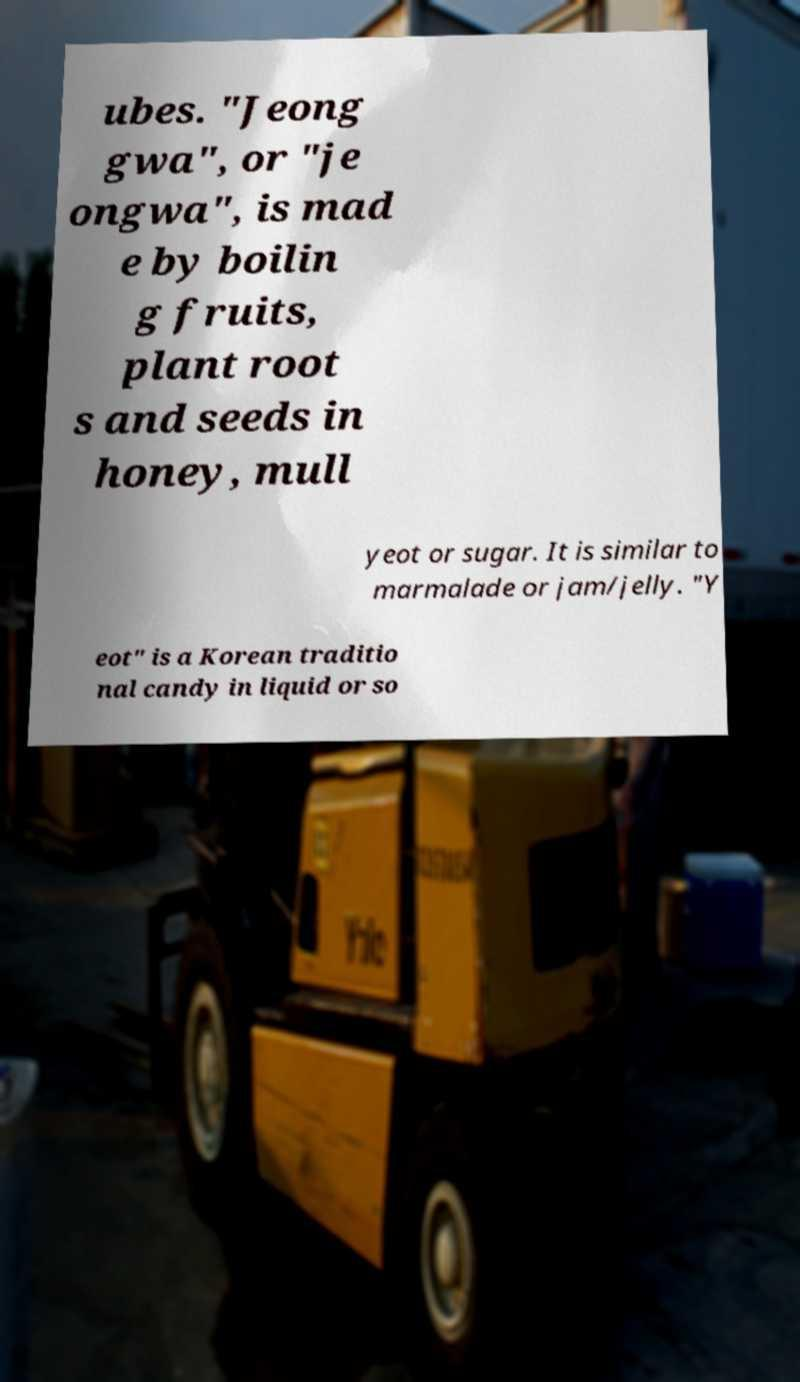Could you extract and type out the text from this image? ubes. "Jeong gwa", or "je ongwa", is mad e by boilin g fruits, plant root s and seeds in honey, mull yeot or sugar. It is similar to marmalade or jam/jelly. "Y eot" is a Korean traditio nal candy in liquid or so 